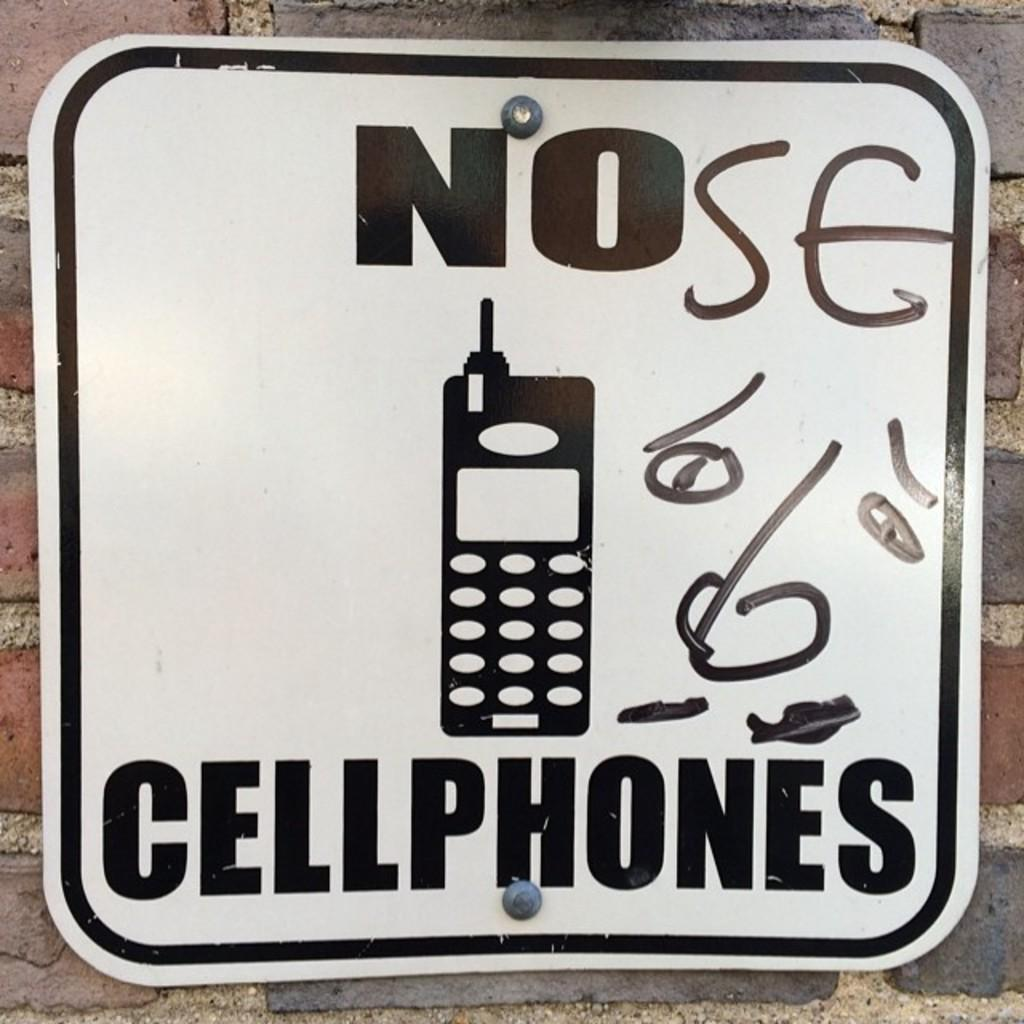<image>
Present a compact description of the photo's key features. someone deface a No cellphones sign to say NOse 